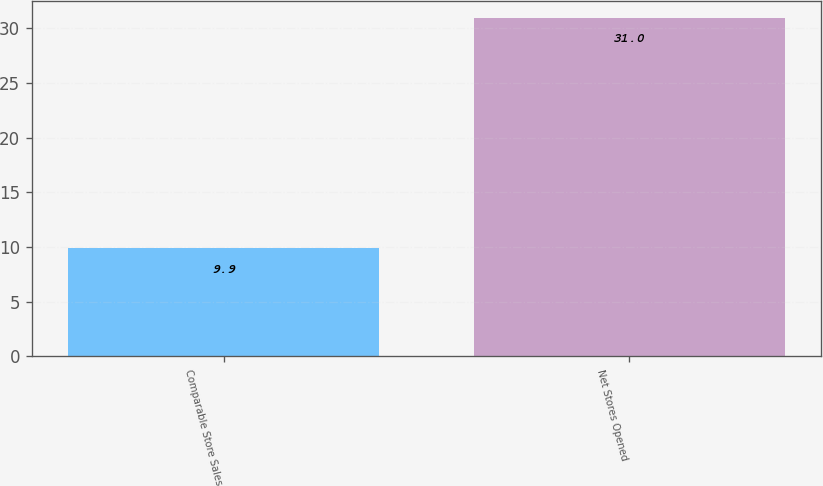<chart> <loc_0><loc_0><loc_500><loc_500><bar_chart><fcel>Comparable Store Sales<fcel>Net Stores Opened<nl><fcel>9.9<fcel>31<nl></chart> 